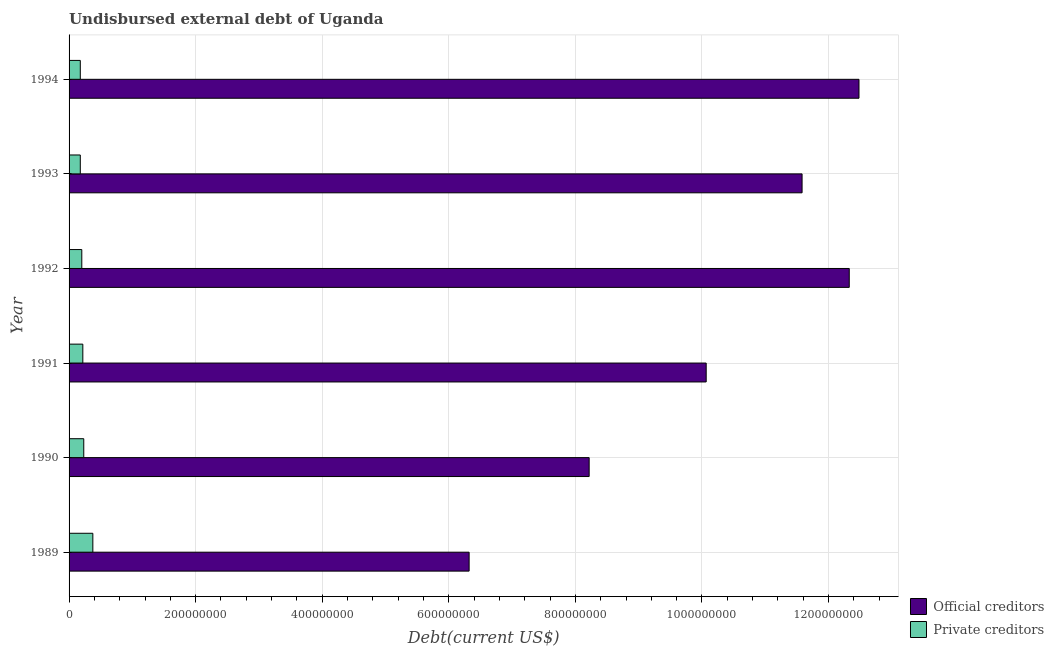How many different coloured bars are there?
Give a very brief answer. 2. How many groups of bars are there?
Your response must be concise. 6. Are the number of bars on each tick of the Y-axis equal?
Offer a very short reply. Yes. How many bars are there on the 6th tick from the top?
Ensure brevity in your answer.  2. How many bars are there on the 3rd tick from the bottom?
Provide a short and direct response. 2. In how many cases, is the number of bars for a given year not equal to the number of legend labels?
Provide a succinct answer. 0. What is the undisbursed external debt of private creditors in 1994?
Offer a terse response. 1.77e+07. Across all years, what is the maximum undisbursed external debt of official creditors?
Offer a very short reply. 1.25e+09. Across all years, what is the minimum undisbursed external debt of private creditors?
Make the answer very short. 1.77e+07. In which year was the undisbursed external debt of official creditors minimum?
Give a very brief answer. 1989. What is the total undisbursed external debt of official creditors in the graph?
Keep it short and to the point. 6.10e+09. What is the difference between the undisbursed external debt of official creditors in 1992 and that in 1993?
Provide a succinct answer. 7.45e+07. What is the difference between the undisbursed external debt of private creditors in 1989 and the undisbursed external debt of official creditors in 1994?
Your answer should be compact. -1.21e+09. What is the average undisbursed external debt of private creditors per year?
Provide a succinct answer. 2.30e+07. In the year 1993, what is the difference between the undisbursed external debt of private creditors and undisbursed external debt of official creditors?
Make the answer very short. -1.14e+09. In how many years, is the undisbursed external debt of private creditors greater than 560000000 US$?
Make the answer very short. 0. What is the ratio of the undisbursed external debt of official creditors in 1991 to that in 1994?
Ensure brevity in your answer.  0.81. Is the undisbursed external debt of private creditors in 1992 less than that in 1993?
Provide a short and direct response. No. Is the difference between the undisbursed external debt of official creditors in 1989 and 1994 greater than the difference between the undisbursed external debt of private creditors in 1989 and 1994?
Keep it short and to the point. No. What is the difference between the highest and the second highest undisbursed external debt of official creditors?
Make the answer very short. 1.54e+07. What is the difference between the highest and the lowest undisbursed external debt of private creditors?
Offer a terse response. 1.98e+07. In how many years, is the undisbursed external debt of private creditors greater than the average undisbursed external debt of private creditors taken over all years?
Offer a terse response. 2. What does the 2nd bar from the top in 1989 represents?
Provide a short and direct response. Official creditors. What does the 1st bar from the bottom in 1993 represents?
Provide a succinct answer. Official creditors. How many years are there in the graph?
Keep it short and to the point. 6. What is the difference between two consecutive major ticks on the X-axis?
Provide a short and direct response. 2.00e+08. Are the values on the major ticks of X-axis written in scientific E-notation?
Your answer should be compact. No. Where does the legend appear in the graph?
Ensure brevity in your answer.  Bottom right. How are the legend labels stacked?
Keep it short and to the point. Vertical. What is the title of the graph?
Your answer should be compact. Undisbursed external debt of Uganda. What is the label or title of the X-axis?
Make the answer very short. Debt(current US$). What is the Debt(current US$) in Official creditors in 1989?
Give a very brief answer. 6.32e+08. What is the Debt(current US$) of Private creditors in 1989?
Your answer should be very brief. 3.76e+07. What is the Debt(current US$) of Official creditors in 1990?
Make the answer very short. 8.22e+08. What is the Debt(current US$) in Private creditors in 1990?
Provide a succinct answer. 2.32e+07. What is the Debt(current US$) in Official creditors in 1991?
Keep it short and to the point. 1.01e+09. What is the Debt(current US$) in Private creditors in 1991?
Ensure brevity in your answer.  2.17e+07. What is the Debt(current US$) in Official creditors in 1992?
Ensure brevity in your answer.  1.23e+09. What is the Debt(current US$) of Private creditors in 1992?
Provide a short and direct response. 2.01e+07. What is the Debt(current US$) in Official creditors in 1993?
Give a very brief answer. 1.16e+09. What is the Debt(current US$) in Private creditors in 1993?
Provide a succinct answer. 1.77e+07. What is the Debt(current US$) in Official creditors in 1994?
Make the answer very short. 1.25e+09. What is the Debt(current US$) in Private creditors in 1994?
Offer a very short reply. 1.77e+07. Across all years, what is the maximum Debt(current US$) of Official creditors?
Your answer should be compact. 1.25e+09. Across all years, what is the maximum Debt(current US$) in Private creditors?
Offer a very short reply. 3.76e+07. Across all years, what is the minimum Debt(current US$) of Official creditors?
Make the answer very short. 6.32e+08. Across all years, what is the minimum Debt(current US$) of Private creditors?
Provide a short and direct response. 1.77e+07. What is the total Debt(current US$) of Official creditors in the graph?
Your answer should be compact. 6.10e+09. What is the total Debt(current US$) in Private creditors in the graph?
Give a very brief answer. 1.38e+08. What is the difference between the Debt(current US$) of Official creditors in 1989 and that in 1990?
Your answer should be very brief. -1.90e+08. What is the difference between the Debt(current US$) in Private creditors in 1989 and that in 1990?
Make the answer very short. 1.44e+07. What is the difference between the Debt(current US$) of Official creditors in 1989 and that in 1991?
Your answer should be very brief. -3.75e+08. What is the difference between the Debt(current US$) of Private creditors in 1989 and that in 1991?
Ensure brevity in your answer.  1.58e+07. What is the difference between the Debt(current US$) in Official creditors in 1989 and that in 1992?
Your answer should be very brief. -6.01e+08. What is the difference between the Debt(current US$) in Private creditors in 1989 and that in 1992?
Offer a terse response. 1.75e+07. What is the difference between the Debt(current US$) of Official creditors in 1989 and that in 1993?
Make the answer very short. -5.26e+08. What is the difference between the Debt(current US$) in Private creditors in 1989 and that in 1993?
Give a very brief answer. 1.98e+07. What is the difference between the Debt(current US$) in Official creditors in 1989 and that in 1994?
Your response must be concise. -6.16e+08. What is the difference between the Debt(current US$) of Private creditors in 1989 and that in 1994?
Provide a short and direct response. 1.98e+07. What is the difference between the Debt(current US$) of Official creditors in 1990 and that in 1991?
Your answer should be very brief. -1.85e+08. What is the difference between the Debt(current US$) in Private creditors in 1990 and that in 1991?
Make the answer very short. 1.48e+06. What is the difference between the Debt(current US$) of Official creditors in 1990 and that in 1992?
Provide a short and direct response. -4.11e+08. What is the difference between the Debt(current US$) of Private creditors in 1990 and that in 1992?
Make the answer very short. 3.12e+06. What is the difference between the Debt(current US$) of Official creditors in 1990 and that in 1993?
Make the answer very short. -3.36e+08. What is the difference between the Debt(current US$) of Private creditors in 1990 and that in 1993?
Keep it short and to the point. 5.49e+06. What is the difference between the Debt(current US$) of Official creditors in 1990 and that in 1994?
Give a very brief answer. -4.26e+08. What is the difference between the Debt(current US$) in Private creditors in 1990 and that in 1994?
Make the answer very short. 5.49e+06. What is the difference between the Debt(current US$) of Official creditors in 1991 and that in 1992?
Offer a terse response. -2.26e+08. What is the difference between the Debt(current US$) of Private creditors in 1991 and that in 1992?
Your answer should be very brief. 1.64e+06. What is the difference between the Debt(current US$) of Official creditors in 1991 and that in 1993?
Your response must be concise. -1.51e+08. What is the difference between the Debt(current US$) in Private creditors in 1991 and that in 1993?
Make the answer very short. 4.00e+06. What is the difference between the Debt(current US$) of Official creditors in 1991 and that in 1994?
Offer a very short reply. -2.41e+08. What is the difference between the Debt(current US$) in Private creditors in 1991 and that in 1994?
Your answer should be compact. 4.00e+06. What is the difference between the Debt(current US$) of Official creditors in 1992 and that in 1993?
Your answer should be compact. 7.45e+07. What is the difference between the Debt(current US$) of Private creditors in 1992 and that in 1993?
Ensure brevity in your answer.  2.36e+06. What is the difference between the Debt(current US$) of Official creditors in 1992 and that in 1994?
Provide a short and direct response. -1.54e+07. What is the difference between the Debt(current US$) in Private creditors in 1992 and that in 1994?
Give a very brief answer. 2.36e+06. What is the difference between the Debt(current US$) in Official creditors in 1993 and that in 1994?
Provide a short and direct response. -8.99e+07. What is the difference between the Debt(current US$) in Private creditors in 1993 and that in 1994?
Offer a terse response. 0. What is the difference between the Debt(current US$) in Official creditors in 1989 and the Debt(current US$) in Private creditors in 1990?
Offer a very short reply. 6.09e+08. What is the difference between the Debt(current US$) in Official creditors in 1989 and the Debt(current US$) in Private creditors in 1991?
Offer a terse response. 6.10e+08. What is the difference between the Debt(current US$) of Official creditors in 1989 and the Debt(current US$) of Private creditors in 1992?
Give a very brief answer. 6.12e+08. What is the difference between the Debt(current US$) in Official creditors in 1989 and the Debt(current US$) in Private creditors in 1993?
Your response must be concise. 6.14e+08. What is the difference between the Debt(current US$) of Official creditors in 1989 and the Debt(current US$) of Private creditors in 1994?
Your response must be concise. 6.14e+08. What is the difference between the Debt(current US$) in Official creditors in 1990 and the Debt(current US$) in Private creditors in 1991?
Keep it short and to the point. 8.00e+08. What is the difference between the Debt(current US$) in Official creditors in 1990 and the Debt(current US$) in Private creditors in 1992?
Ensure brevity in your answer.  8.02e+08. What is the difference between the Debt(current US$) of Official creditors in 1990 and the Debt(current US$) of Private creditors in 1993?
Offer a very short reply. 8.04e+08. What is the difference between the Debt(current US$) in Official creditors in 1990 and the Debt(current US$) in Private creditors in 1994?
Keep it short and to the point. 8.04e+08. What is the difference between the Debt(current US$) of Official creditors in 1991 and the Debt(current US$) of Private creditors in 1992?
Offer a very short reply. 9.87e+08. What is the difference between the Debt(current US$) in Official creditors in 1991 and the Debt(current US$) in Private creditors in 1993?
Offer a very short reply. 9.89e+08. What is the difference between the Debt(current US$) of Official creditors in 1991 and the Debt(current US$) of Private creditors in 1994?
Your answer should be compact. 9.89e+08. What is the difference between the Debt(current US$) of Official creditors in 1992 and the Debt(current US$) of Private creditors in 1993?
Your answer should be very brief. 1.21e+09. What is the difference between the Debt(current US$) of Official creditors in 1992 and the Debt(current US$) of Private creditors in 1994?
Offer a terse response. 1.21e+09. What is the difference between the Debt(current US$) in Official creditors in 1993 and the Debt(current US$) in Private creditors in 1994?
Provide a succinct answer. 1.14e+09. What is the average Debt(current US$) in Official creditors per year?
Your response must be concise. 1.02e+09. What is the average Debt(current US$) in Private creditors per year?
Provide a succinct answer. 2.30e+07. In the year 1989, what is the difference between the Debt(current US$) of Official creditors and Debt(current US$) of Private creditors?
Make the answer very short. 5.95e+08. In the year 1990, what is the difference between the Debt(current US$) in Official creditors and Debt(current US$) in Private creditors?
Give a very brief answer. 7.99e+08. In the year 1991, what is the difference between the Debt(current US$) in Official creditors and Debt(current US$) in Private creditors?
Offer a very short reply. 9.85e+08. In the year 1992, what is the difference between the Debt(current US$) in Official creditors and Debt(current US$) in Private creditors?
Ensure brevity in your answer.  1.21e+09. In the year 1993, what is the difference between the Debt(current US$) in Official creditors and Debt(current US$) in Private creditors?
Your answer should be very brief. 1.14e+09. In the year 1994, what is the difference between the Debt(current US$) of Official creditors and Debt(current US$) of Private creditors?
Offer a terse response. 1.23e+09. What is the ratio of the Debt(current US$) in Official creditors in 1989 to that in 1990?
Make the answer very short. 0.77. What is the ratio of the Debt(current US$) of Private creditors in 1989 to that in 1990?
Make the answer very short. 1.62. What is the ratio of the Debt(current US$) of Official creditors in 1989 to that in 1991?
Your response must be concise. 0.63. What is the ratio of the Debt(current US$) in Private creditors in 1989 to that in 1991?
Ensure brevity in your answer.  1.73. What is the ratio of the Debt(current US$) in Official creditors in 1989 to that in 1992?
Make the answer very short. 0.51. What is the ratio of the Debt(current US$) of Private creditors in 1989 to that in 1992?
Your answer should be very brief. 1.87. What is the ratio of the Debt(current US$) of Official creditors in 1989 to that in 1993?
Offer a very short reply. 0.55. What is the ratio of the Debt(current US$) of Private creditors in 1989 to that in 1993?
Provide a short and direct response. 2.12. What is the ratio of the Debt(current US$) in Official creditors in 1989 to that in 1994?
Keep it short and to the point. 0.51. What is the ratio of the Debt(current US$) of Private creditors in 1989 to that in 1994?
Provide a succinct answer. 2.12. What is the ratio of the Debt(current US$) of Official creditors in 1990 to that in 1991?
Provide a succinct answer. 0.82. What is the ratio of the Debt(current US$) of Private creditors in 1990 to that in 1991?
Offer a terse response. 1.07. What is the ratio of the Debt(current US$) of Official creditors in 1990 to that in 1992?
Provide a short and direct response. 0.67. What is the ratio of the Debt(current US$) in Private creditors in 1990 to that in 1992?
Offer a very short reply. 1.16. What is the ratio of the Debt(current US$) of Official creditors in 1990 to that in 1993?
Your answer should be compact. 0.71. What is the ratio of the Debt(current US$) in Private creditors in 1990 to that in 1993?
Give a very brief answer. 1.31. What is the ratio of the Debt(current US$) in Official creditors in 1990 to that in 1994?
Make the answer very short. 0.66. What is the ratio of the Debt(current US$) of Private creditors in 1990 to that in 1994?
Your answer should be compact. 1.31. What is the ratio of the Debt(current US$) in Official creditors in 1991 to that in 1992?
Ensure brevity in your answer.  0.82. What is the ratio of the Debt(current US$) of Private creditors in 1991 to that in 1992?
Provide a succinct answer. 1.08. What is the ratio of the Debt(current US$) in Official creditors in 1991 to that in 1993?
Make the answer very short. 0.87. What is the ratio of the Debt(current US$) in Private creditors in 1991 to that in 1993?
Give a very brief answer. 1.23. What is the ratio of the Debt(current US$) in Official creditors in 1991 to that in 1994?
Ensure brevity in your answer.  0.81. What is the ratio of the Debt(current US$) in Private creditors in 1991 to that in 1994?
Offer a terse response. 1.23. What is the ratio of the Debt(current US$) of Official creditors in 1992 to that in 1993?
Your answer should be very brief. 1.06. What is the ratio of the Debt(current US$) in Private creditors in 1992 to that in 1993?
Your answer should be very brief. 1.13. What is the ratio of the Debt(current US$) in Official creditors in 1992 to that in 1994?
Provide a succinct answer. 0.99. What is the ratio of the Debt(current US$) of Private creditors in 1992 to that in 1994?
Provide a succinct answer. 1.13. What is the ratio of the Debt(current US$) in Official creditors in 1993 to that in 1994?
Give a very brief answer. 0.93. What is the difference between the highest and the second highest Debt(current US$) in Official creditors?
Provide a succinct answer. 1.54e+07. What is the difference between the highest and the second highest Debt(current US$) of Private creditors?
Keep it short and to the point. 1.44e+07. What is the difference between the highest and the lowest Debt(current US$) in Official creditors?
Your response must be concise. 6.16e+08. What is the difference between the highest and the lowest Debt(current US$) of Private creditors?
Provide a succinct answer. 1.98e+07. 